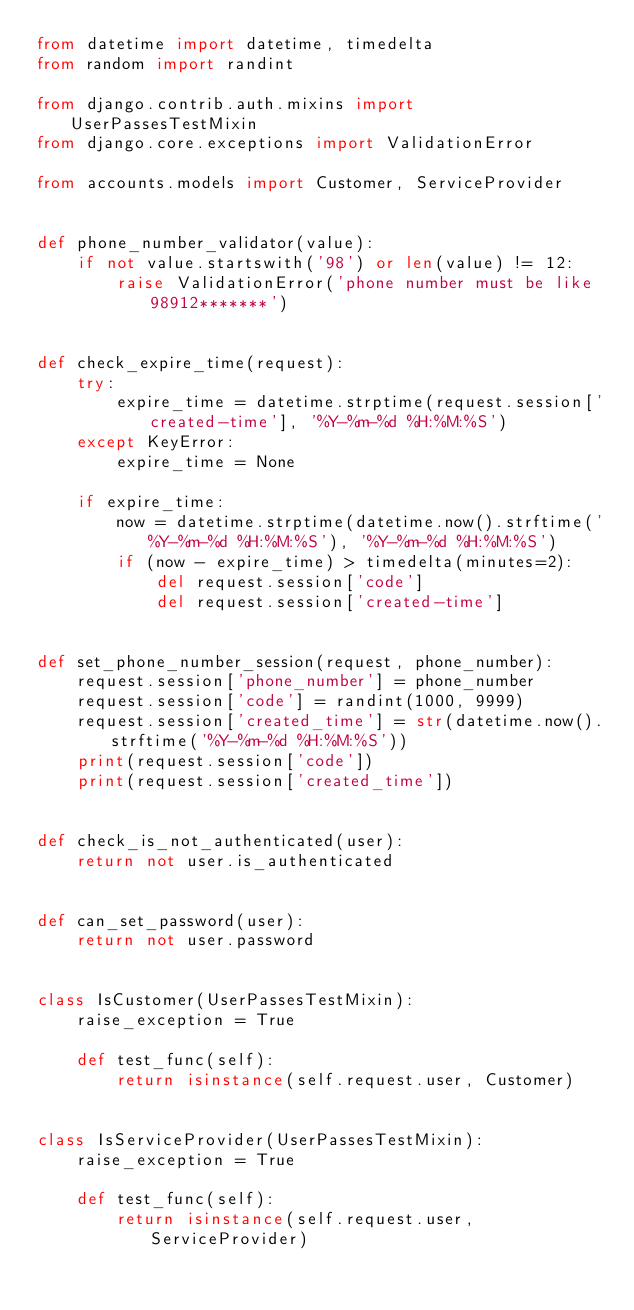<code> <loc_0><loc_0><loc_500><loc_500><_Python_>from datetime import datetime, timedelta
from random import randint

from django.contrib.auth.mixins import UserPassesTestMixin
from django.core.exceptions import ValidationError

from accounts.models import Customer, ServiceProvider


def phone_number_validator(value):
    if not value.startswith('98') or len(value) != 12:
        raise ValidationError('phone number must be like 98912*******')


def check_expire_time(request):
    try:
        expire_time = datetime.strptime(request.session['created-time'], '%Y-%m-%d %H:%M:%S')
    except KeyError:
        expire_time = None

    if expire_time:
        now = datetime.strptime(datetime.now().strftime('%Y-%m-%d %H:%M:%S'), '%Y-%m-%d %H:%M:%S')
        if (now - expire_time) > timedelta(minutes=2):
            del request.session['code']
            del request.session['created-time']


def set_phone_number_session(request, phone_number):
    request.session['phone_number'] = phone_number
    request.session['code'] = randint(1000, 9999)
    request.session['created_time'] = str(datetime.now().strftime('%Y-%m-%d %H:%M:%S'))
    print(request.session['code'])
    print(request.session['created_time'])


def check_is_not_authenticated(user):
    return not user.is_authenticated


def can_set_password(user):
    return not user.password


class IsCustomer(UserPassesTestMixin):
    raise_exception = True

    def test_func(self):
        return isinstance(self.request.user, Customer)


class IsServiceProvider(UserPassesTestMixin):
    raise_exception = True

    def test_func(self):
        return isinstance(self.request.user, ServiceProvider)
</code> 